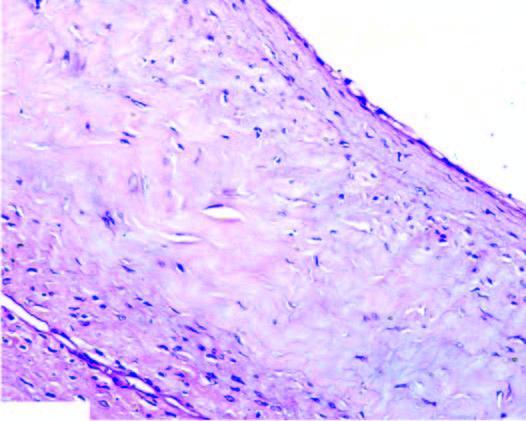does the cyst wall show myxoid degeneration?
Answer the question using a single word or phrase. Yes 